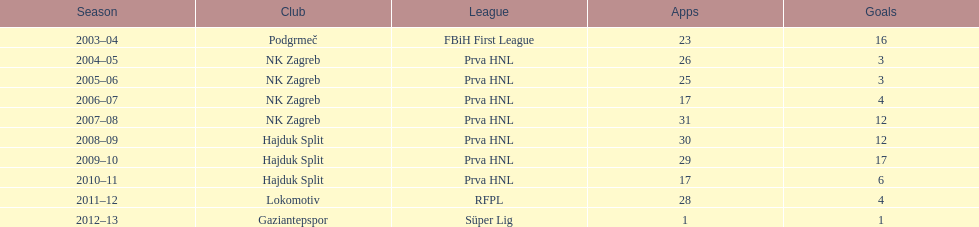Considering a limit of 26 apps, how many goals were scored in the 2004-2005 timeframe? 3. 